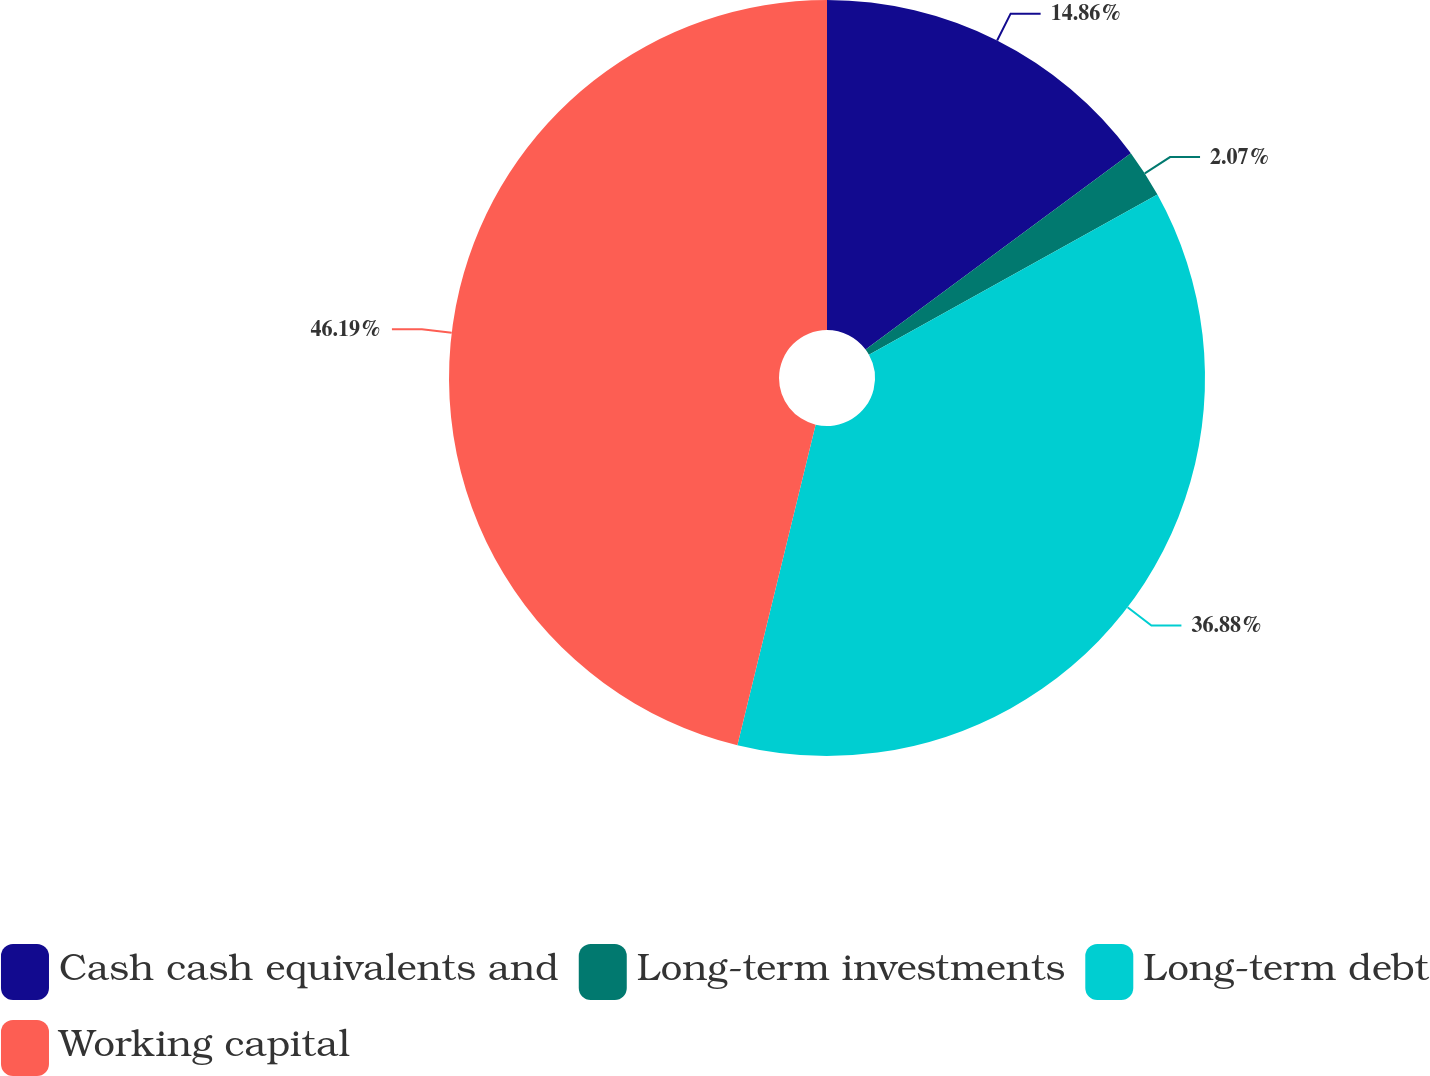<chart> <loc_0><loc_0><loc_500><loc_500><pie_chart><fcel>Cash cash equivalents and<fcel>Long-term investments<fcel>Long-term debt<fcel>Working capital<nl><fcel>14.86%<fcel>2.07%<fcel>36.88%<fcel>46.19%<nl></chart> 